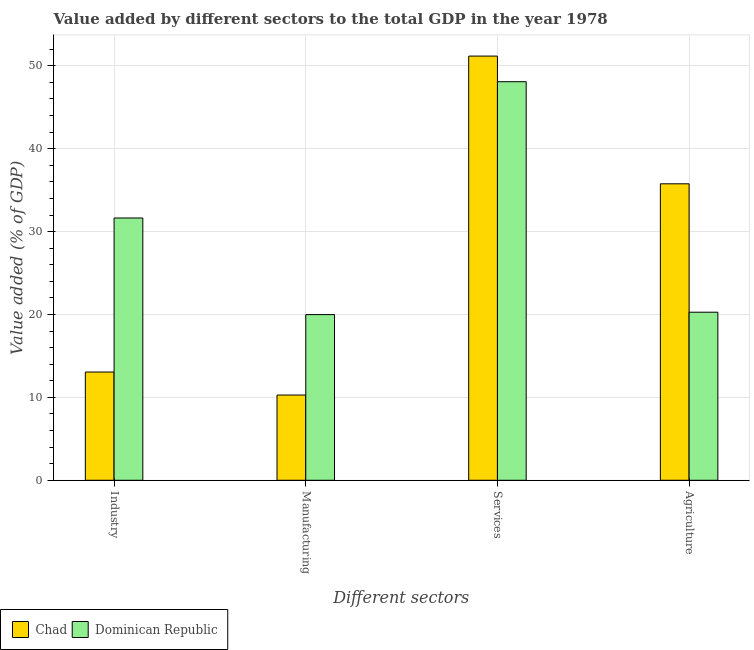How many different coloured bars are there?
Your answer should be compact. 2. How many groups of bars are there?
Make the answer very short. 4. Are the number of bars per tick equal to the number of legend labels?
Make the answer very short. Yes. How many bars are there on the 2nd tick from the left?
Give a very brief answer. 2. How many bars are there on the 1st tick from the right?
Your response must be concise. 2. What is the label of the 2nd group of bars from the left?
Provide a succinct answer. Manufacturing. What is the value added by services sector in Dominican Republic?
Keep it short and to the point. 48.08. Across all countries, what is the maximum value added by services sector?
Keep it short and to the point. 51.18. Across all countries, what is the minimum value added by services sector?
Give a very brief answer. 48.08. In which country was the value added by services sector maximum?
Provide a short and direct response. Chad. In which country was the value added by manufacturing sector minimum?
Make the answer very short. Chad. What is the total value added by agricultural sector in the graph?
Ensure brevity in your answer.  56.04. What is the difference between the value added by agricultural sector in Dominican Republic and that in Chad?
Offer a terse response. -15.49. What is the difference between the value added by agricultural sector in Chad and the value added by industrial sector in Dominican Republic?
Your answer should be very brief. 4.12. What is the average value added by services sector per country?
Your response must be concise. 49.63. What is the difference between the value added by industrial sector and value added by agricultural sector in Chad?
Provide a short and direct response. -22.71. In how many countries, is the value added by agricultural sector greater than 38 %?
Keep it short and to the point. 0. What is the ratio of the value added by industrial sector in Dominican Republic to that in Chad?
Your response must be concise. 2.42. Is the value added by manufacturing sector in Chad less than that in Dominican Republic?
Give a very brief answer. Yes. Is the difference between the value added by industrial sector in Chad and Dominican Republic greater than the difference between the value added by manufacturing sector in Chad and Dominican Republic?
Your answer should be very brief. No. What is the difference between the highest and the second highest value added by agricultural sector?
Your response must be concise. 15.49. What is the difference between the highest and the lowest value added by industrial sector?
Give a very brief answer. 18.58. In how many countries, is the value added by industrial sector greater than the average value added by industrial sector taken over all countries?
Your response must be concise. 1. Is the sum of the value added by services sector in Chad and Dominican Republic greater than the maximum value added by industrial sector across all countries?
Your response must be concise. Yes. Is it the case that in every country, the sum of the value added by manufacturing sector and value added by industrial sector is greater than the sum of value added by services sector and value added by agricultural sector?
Provide a short and direct response. No. What does the 2nd bar from the left in Agriculture represents?
Offer a terse response. Dominican Republic. What does the 1st bar from the right in Industry represents?
Provide a succinct answer. Dominican Republic. Are all the bars in the graph horizontal?
Offer a terse response. No. What is the difference between two consecutive major ticks on the Y-axis?
Keep it short and to the point. 10. Where does the legend appear in the graph?
Your answer should be very brief. Bottom left. How are the legend labels stacked?
Make the answer very short. Horizontal. What is the title of the graph?
Keep it short and to the point. Value added by different sectors to the total GDP in the year 1978. What is the label or title of the X-axis?
Give a very brief answer. Different sectors. What is the label or title of the Y-axis?
Offer a very short reply. Value added (% of GDP). What is the Value added (% of GDP) in Chad in Industry?
Make the answer very short. 13.06. What is the Value added (% of GDP) in Dominican Republic in Industry?
Provide a short and direct response. 31.64. What is the Value added (% of GDP) in Chad in Manufacturing?
Offer a terse response. 10.28. What is the Value added (% of GDP) in Dominican Republic in Manufacturing?
Keep it short and to the point. 19.99. What is the Value added (% of GDP) in Chad in Services?
Give a very brief answer. 51.18. What is the Value added (% of GDP) in Dominican Republic in Services?
Keep it short and to the point. 48.08. What is the Value added (% of GDP) of Chad in Agriculture?
Offer a terse response. 35.77. What is the Value added (% of GDP) in Dominican Republic in Agriculture?
Your answer should be compact. 20.27. Across all Different sectors, what is the maximum Value added (% of GDP) in Chad?
Offer a very short reply. 51.18. Across all Different sectors, what is the maximum Value added (% of GDP) in Dominican Republic?
Your response must be concise. 48.08. Across all Different sectors, what is the minimum Value added (% of GDP) in Chad?
Your answer should be compact. 10.28. Across all Different sectors, what is the minimum Value added (% of GDP) of Dominican Republic?
Your answer should be compact. 19.99. What is the total Value added (% of GDP) of Chad in the graph?
Ensure brevity in your answer.  110.28. What is the total Value added (% of GDP) in Dominican Republic in the graph?
Keep it short and to the point. 119.99. What is the difference between the Value added (% of GDP) of Chad in Industry and that in Manufacturing?
Provide a succinct answer. 2.78. What is the difference between the Value added (% of GDP) in Dominican Republic in Industry and that in Manufacturing?
Offer a very short reply. 11.66. What is the difference between the Value added (% of GDP) of Chad in Industry and that in Services?
Make the answer very short. -38.12. What is the difference between the Value added (% of GDP) in Dominican Republic in Industry and that in Services?
Offer a very short reply. -16.44. What is the difference between the Value added (% of GDP) in Chad in Industry and that in Agriculture?
Your answer should be very brief. -22.71. What is the difference between the Value added (% of GDP) in Dominican Republic in Industry and that in Agriculture?
Provide a short and direct response. 11.37. What is the difference between the Value added (% of GDP) of Chad in Manufacturing and that in Services?
Your answer should be compact. -40.89. What is the difference between the Value added (% of GDP) in Dominican Republic in Manufacturing and that in Services?
Keep it short and to the point. -28.1. What is the difference between the Value added (% of GDP) of Chad in Manufacturing and that in Agriculture?
Make the answer very short. -25.48. What is the difference between the Value added (% of GDP) in Dominican Republic in Manufacturing and that in Agriculture?
Make the answer very short. -0.29. What is the difference between the Value added (% of GDP) in Chad in Services and that in Agriculture?
Give a very brief answer. 15.41. What is the difference between the Value added (% of GDP) in Dominican Republic in Services and that in Agriculture?
Give a very brief answer. 27.81. What is the difference between the Value added (% of GDP) in Chad in Industry and the Value added (% of GDP) in Dominican Republic in Manufacturing?
Provide a succinct answer. -6.93. What is the difference between the Value added (% of GDP) in Chad in Industry and the Value added (% of GDP) in Dominican Republic in Services?
Provide a succinct answer. -35.02. What is the difference between the Value added (% of GDP) in Chad in Industry and the Value added (% of GDP) in Dominican Republic in Agriculture?
Keep it short and to the point. -7.22. What is the difference between the Value added (% of GDP) in Chad in Manufacturing and the Value added (% of GDP) in Dominican Republic in Services?
Keep it short and to the point. -37.8. What is the difference between the Value added (% of GDP) in Chad in Manufacturing and the Value added (% of GDP) in Dominican Republic in Agriculture?
Make the answer very short. -9.99. What is the difference between the Value added (% of GDP) in Chad in Services and the Value added (% of GDP) in Dominican Republic in Agriculture?
Your response must be concise. 30.9. What is the average Value added (% of GDP) in Chad per Different sectors?
Give a very brief answer. 27.57. What is the average Value added (% of GDP) of Dominican Republic per Different sectors?
Your response must be concise. 30. What is the difference between the Value added (% of GDP) in Chad and Value added (% of GDP) in Dominican Republic in Industry?
Keep it short and to the point. -18.58. What is the difference between the Value added (% of GDP) in Chad and Value added (% of GDP) in Dominican Republic in Manufacturing?
Your answer should be very brief. -9.7. What is the difference between the Value added (% of GDP) of Chad and Value added (% of GDP) of Dominican Republic in Services?
Give a very brief answer. 3.09. What is the difference between the Value added (% of GDP) in Chad and Value added (% of GDP) in Dominican Republic in Agriculture?
Your answer should be compact. 15.49. What is the ratio of the Value added (% of GDP) in Chad in Industry to that in Manufacturing?
Your response must be concise. 1.27. What is the ratio of the Value added (% of GDP) of Dominican Republic in Industry to that in Manufacturing?
Your answer should be compact. 1.58. What is the ratio of the Value added (% of GDP) in Chad in Industry to that in Services?
Keep it short and to the point. 0.26. What is the ratio of the Value added (% of GDP) of Dominican Republic in Industry to that in Services?
Your answer should be very brief. 0.66. What is the ratio of the Value added (% of GDP) of Chad in Industry to that in Agriculture?
Keep it short and to the point. 0.37. What is the ratio of the Value added (% of GDP) of Dominican Republic in Industry to that in Agriculture?
Provide a short and direct response. 1.56. What is the ratio of the Value added (% of GDP) of Chad in Manufacturing to that in Services?
Your response must be concise. 0.2. What is the ratio of the Value added (% of GDP) in Dominican Republic in Manufacturing to that in Services?
Make the answer very short. 0.42. What is the ratio of the Value added (% of GDP) in Chad in Manufacturing to that in Agriculture?
Keep it short and to the point. 0.29. What is the ratio of the Value added (% of GDP) in Dominican Republic in Manufacturing to that in Agriculture?
Your response must be concise. 0.99. What is the ratio of the Value added (% of GDP) of Chad in Services to that in Agriculture?
Offer a terse response. 1.43. What is the ratio of the Value added (% of GDP) in Dominican Republic in Services to that in Agriculture?
Your response must be concise. 2.37. What is the difference between the highest and the second highest Value added (% of GDP) in Chad?
Your answer should be very brief. 15.41. What is the difference between the highest and the second highest Value added (% of GDP) of Dominican Republic?
Offer a terse response. 16.44. What is the difference between the highest and the lowest Value added (% of GDP) of Chad?
Offer a very short reply. 40.89. What is the difference between the highest and the lowest Value added (% of GDP) of Dominican Republic?
Your response must be concise. 28.1. 